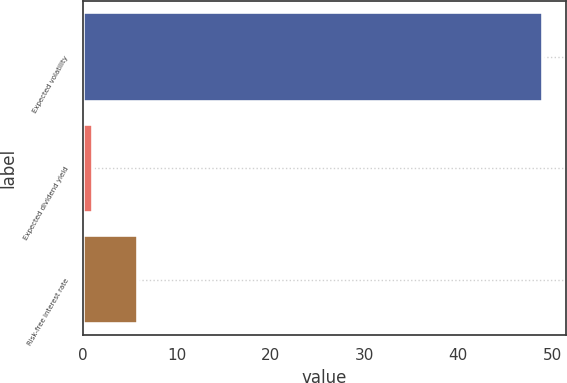Convert chart to OTSL. <chart><loc_0><loc_0><loc_500><loc_500><bar_chart><fcel>Expected volatility<fcel>Expected dividend yield<fcel>Risk-free interest rate<nl><fcel>48.96<fcel>1.1<fcel>5.89<nl></chart> 